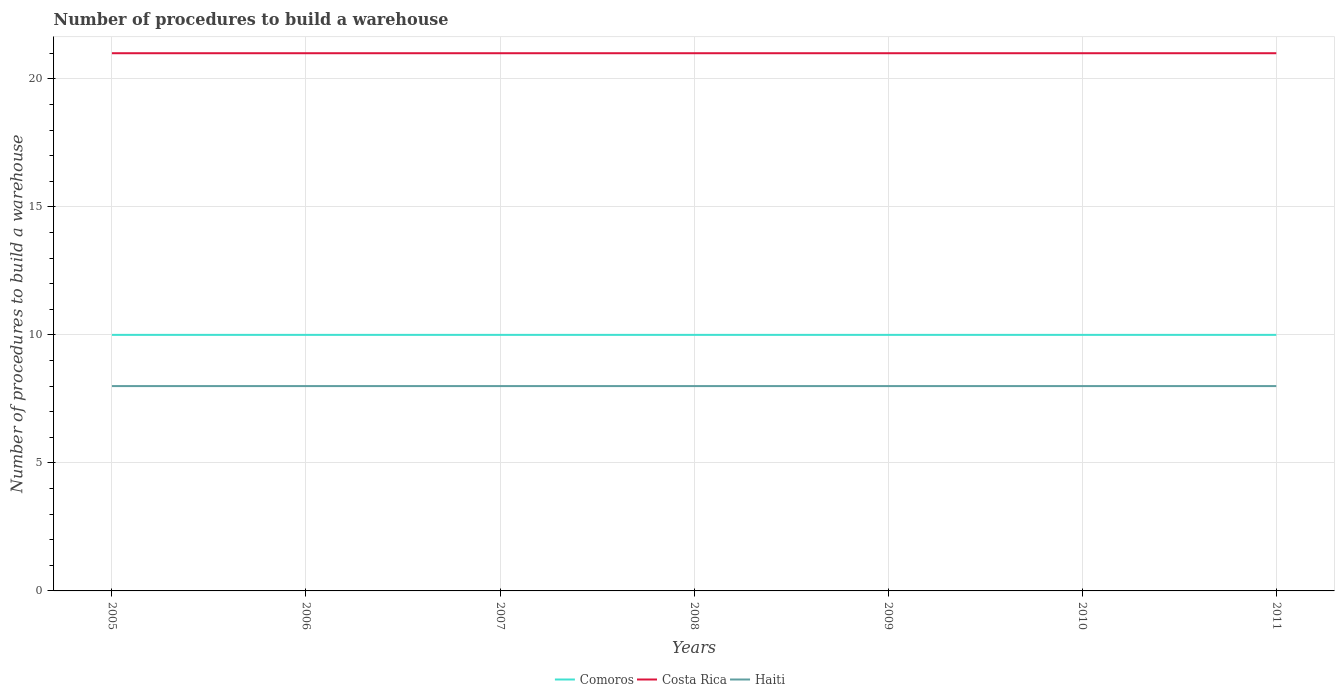Does the line corresponding to Costa Rica intersect with the line corresponding to Haiti?
Your answer should be very brief. No. Across all years, what is the maximum number of procedures to build a warehouse in in Costa Rica?
Your answer should be compact. 21. In which year was the number of procedures to build a warehouse in in Comoros maximum?
Ensure brevity in your answer.  2005. What is the total number of procedures to build a warehouse in in Haiti in the graph?
Provide a succinct answer. 0. What is the difference between the highest and the lowest number of procedures to build a warehouse in in Comoros?
Provide a succinct answer. 0. Are the values on the major ticks of Y-axis written in scientific E-notation?
Provide a short and direct response. No. Does the graph contain grids?
Your answer should be very brief. Yes. How many legend labels are there?
Offer a terse response. 3. What is the title of the graph?
Keep it short and to the point. Number of procedures to build a warehouse. Does "Lesotho" appear as one of the legend labels in the graph?
Your response must be concise. No. What is the label or title of the Y-axis?
Your answer should be very brief. Number of procedures to build a warehouse. What is the Number of procedures to build a warehouse in Costa Rica in 2005?
Your response must be concise. 21. What is the Number of procedures to build a warehouse of Comoros in 2006?
Your answer should be very brief. 10. What is the Number of procedures to build a warehouse of Costa Rica in 2006?
Your response must be concise. 21. What is the Number of procedures to build a warehouse in Haiti in 2006?
Your answer should be very brief. 8. What is the Number of procedures to build a warehouse in Costa Rica in 2007?
Make the answer very short. 21. What is the Number of procedures to build a warehouse in Comoros in 2008?
Provide a short and direct response. 10. What is the Number of procedures to build a warehouse in Costa Rica in 2009?
Ensure brevity in your answer.  21. What is the Number of procedures to build a warehouse of Haiti in 2010?
Provide a succinct answer. 8. What is the Number of procedures to build a warehouse of Comoros in 2011?
Your answer should be very brief. 10. What is the Number of procedures to build a warehouse of Costa Rica in 2011?
Make the answer very short. 21. Across all years, what is the maximum Number of procedures to build a warehouse of Comoros?
Offer a terse response. 10. Across all years, what is the maximum Number of procedures to build a warehouse in Haiti?
Your response must be concise. 8. Across all years, what is the minimum Number of procedures to build a warehouse in Comoros?
Give a very brief answer. 10. What is the total Number of procedures to build a warehouse of Costa Rica in the graph?
Your answer should be very brief. 147. What is the difference between the Number of procedures to build a warehouse of Comoros in 2005 and that in 2006?
Offer a very short reply. 0. What is the difference between the Number of procedures to build a warehouse in Costa Rica in 2005 and that in 2006?
Make the answer very short. 0. What is the difference between the Number of procedures to build a warehouse in Haiti in 2005 and that in 2006?
Your response must be concise. 0. What is the difference between the Number of procedures to build a warehouse of Comoros in 2005 and that in 2007?
Your response must be concise. 0. What is the difference between the Number of procedures to build a warehouse in Haiti in 2005 and that in 2007?
Ensure brevity in your answer.  0. What is the difference between the Number of procedures to build a warehouse in Comoros in 2005 and that in 2009?
Offer a very short reply. 0. What is the difference between the Number of procedures to build a warehouse of Costa Rica in 2005 and that in 2009?
Ensure brevity in your answer.  0. What is the difference between the Number of procedures to build a warehouse of Costa Rica in 2005 and that in 2010?
Provide a short and direct response. 0. What is the difference between the Number of procedures to build a warehouse in Haiti in 2005 and that in 2011?
Make the answer very short. 0. What is the difference between the Number of procedures to build a warehouse of Comoros in 2006 and that in 2008?
Provide a short and direct response. 0. What is the difference between the Number of procedures to build a warehouse of Costa Rica in 2006 and that in 2008?
Your answer should be very brief. 0. What is the difference between the Number of procedures to build a warehouse in Haiti in 2006 and that in 2008?
Make the answer very short. 0. What is the difference between the Number of procedures to build a warehouse in Costa Rica in 2006 and that in 2009?
Your answer should be very brief. 0. What is the difference between the Number of procedures to build a warehouse in Haiti in 2006 and that in 2009?
Keep it short and to the point. 0. What is the difference between the Number of procedures to build a warehouse in Costa Rica in 2006 and that in 2010?
Provide a short and direct response. 0. What is the difference between the Number of procedures to build a warehouse of Comoros in 2007 and that in 2008?
Give a very brief answer. 0. What is the difference between the Number of procedures to build a warehouse of Haiti in 2007 and that in 2008?
Offer a very short reply. 0. What is the difference between the Number of procedures to build a warehouse in Costa Rica in 2007 and that in 2009?
Provide a succinct answer. 0. What is the difference between the Number of procedures to build a warehouse in Costa Rica in 2007 and that in 2010?
Keep it short and to the point. 0. What is the difference between the Number of procedures to build a warehouse of Haiti in 2007 and that in 2010?
Your response must be concise. 0. What is the difference between the Number of procedures to build a warehouse in Comoros in 2007 and that in 2011?
Ensure brevity in your answer.  0. What is the difference between the Number of procedures to build a warehouse of Haiti in 2008 and that in 2009?
Keep it short and to the point. 0. What is the difference between the Number of procedures to build a warehouse in Comoros in 2008 and that in 2010?
Make the answer very short. 0. What is the difference between the Number of procedures to build a warehouse in Costa Rica in 2008 and that in 2010?
Offer a very short reply. 0. What is the difference between the Number of procedures to build a warehouse of Haiti in 2008 and that in 2010?
Keep it short and to the point. 0. What is the difference between the Number of procedures to build a warehouse in Comoros in 2008 and that in 2011?
Provide a succinct answer. 0. What is the difference between the Number of procedures to build a warehouse of Haiti in 2008 and that in 2011?
Give a very brief answer. 0. What is the difference between the Number of procedures to build a warehouse in Costa Rica in 2009 and that in 2011?
Provide a short and direct response. 0. What is the difference between the Number of procedures to build a warehouse in Haiti in 2010 and that in 2011?
Your response must be concise. 0. What is the difference between the Number of procedures to build a warehouse of Comoros in 2005 and the Number of procedures to build a warehouse of Costa Rica in 2006?
Offer a very short reply. -11. What is the difference between the Number of procedures to build a warehouse in Costa Rica in 2005 and the Number of procedures to build a warehouse in Haiti in 2006?
Offer a terse response. 13. What is the difference between the Number of procedures to build a warehouse of Comoros in 2005 and the Number of procedures to build a warehouse of Haiti in 2007?
Provide a succinct answer. 2. What is the difference between the Number of procedures to build a warehouse in Comoros in 2005 and the Number of procedures to build a warehouse in Costa Rica in 2009?
Your response must be concise. -11. What is the difference between the Number of procedures to build a warehouse in Costa Rica in 2005 and the Number of procedures to build a warehouse in Haiti in 2009?
Ensure brevity in your answer.  13. What is the difference between the Number of procedures to build a warehouse of Comoros in 2005 and the Number of procedures to build a warehouse of Costa Rica in 2010?
Give a very brief answer. -11. What is the difference between the Number of procedures to build a warehouse in Comoros in 2005 and the Number of procedures to build a warehouse in Haiti in 2010?
Your answer should be very brief. 2. What is the difference between the Number of procedures to build a warehouse in Costa Rica in 2005 and the Number of procedures to build a warehouse in Haiti in 2010?
Keep it short and to the point. 13. What is the difference between the Number of procedures to build a warehouse in Comoros in 2005 and the Number of procedures to build a warehouse in Costa Rica in 2011?
Your answer should be very brief. -11. What is the difference between the Number of procedures to build a warehouse of Comoros in 2005 and the Number of procedures to build a warehouse of Haiti in 2011?
Offer a very short reply. 2. What is the difference between the Number of procedures to build a warehouse of Comoros in 2006 and the Number of procedures to build a warehouse of Haiti in 2007?
Offer a terse response. 2. What is the difference between the Number of procedures to build a warehouse of Comoros in 2006 and the Number of procedures to build a warehouse of Costa Rica in 2008?
Keep it short and to the point. -11. What is the difference between the Number of procedures to build a warehouse in Comoros in 2006 and the Number of procedures to build a warehouse in Haiti in 2010?
Keep it short and to the point. 2. What is the difference between the Number of procedures to build a warehouse of Costa Rica in 2006 and the Number of procedures to build a warehouse of Haiti in 2010?
Your response must be concise. 13. What is the difference between the Number of procedures to build a warehouse of Comoros in 2007 and the Number of procedures to build a warehouse of Costa Rica in 2008?
Offer a very short reply. -11. What is the difference between the Number of procedures to build a warehouse of Comoros in 2007 and the Number of procedures to build a warehouse of Haiti in 2008?
Offer a very short reply. 2. What is the difference between the Number of procedures to build a warehouse in Costa Rica in 2007 and the Number of procedures to build a warehouse in Haiti in 2008?
Offer a terse response. 13. What is the difference between the Number of procedures to build a warehouse in Comoros in 2007 and the Number of procedures to build a warehouse in Haiti in 2009?
Keep it short and to the point. 2. What is the difference between the Number of procedures to build a warehouse in Costa Rica in 2007 and the Number of procedures to build a warehouse in Haiti in 2009?
Keep it short and to the point. 13. What is the difference between the Number of procedures to build a warehouse of Comoros in 2007 and the Number of procedures to build a warehouse of Costa Rica in 2011?
Offer a terse response. -11. What is the difference between the Number of procedures to build a warehouse of Comoros in 2007 and the Number of procedures to build a warehouse of Haiti in 2011?
Ensure brevity in your answer.  2. What is the difference between the Number of procedures to build a warehouse in Comoros in 2008 and the Number of procedures to build a warehouse in Costa Rica in 2009?
Offer a terse response. -11. What is the difference between the Number of procedures to build a warehouse of Comoros in 2008 and the Number of procedures to build a warehouse of Costa Rica in 2010?
Your answer should be very brief. -11. What is the difference between the Number of procedures to build a warehouse of Comoros in 2008 and the Number of procedures to build a warehouse of Haiti in 2010?
Your response must be concise. 2. What is the difference between the Number of procedures to build a warehouse in Comoros in 2008 and the Number of procedures to build a warehouse in Costa Rica in 2011?
Provide a succinct answer. -11. What is the difference between the Number of procedures to build a warehouse of Comoros in 2009 and the Number of procedures to build a warehouse of Haiti in 2010?
Provide a succinct answer. 2. What is the difference between the Number of procedures to build a warehouse of Costa Rica in 2009 and the Number of procedures to build a warehouse of Haiti in 2010?
Make the answer very short. 13. What is the difference between the Number of procedures to build a warehouse in Comoros in 2009 and the Number of procedures to build a warehouse in Costa Rica in 2011?
Keep it short and to the point. -11. What is the difference between the Number of procedures to build a warehouse in Comoros in 2009 and the Number of procedures to build a warehouse in Haiti in 2011?
Your answer should be very brief. 2. What is the difference between the Number of procedures to build a warehouse of Costa Rica in 2010 and the Number of procedures to build a warehouse of Haiti in 2011?
Ensure brevity in your answer.  13. What is the average Number of procedures to build a warehouse in Costa Rica per year?
Offer a very short reply. 21. In the year 2005, what is the difference between the Number of procedures to build a warehouse in Costa Rica and Number of procedures to build a warehouse in Haiti?
Keep it short and to the point. 13. In the year 2006, what is the difference between the Number of procedures to build a warehouse in Comoros and Number of procedures to build a warehouse in Haiti?
Make the answer very short. 2. In the year 2007, what is the difference between the Number of procedures to build a warehouse in Comoros and Number of procedures to build a warehouse in Costa Rica?
Your answer should be compact. -11. In the year 2007, what is the difference between the Number of procedures to build a warehouse of Costa Rica and Number of procedures to build a warehouse of Haiti?
Keep it short and to the point. 13. In the year 2008, what is the difference between the Number of procedures to build a warehouse in Comoros and Number of procedures to build a warehouse in Costa Rica?
Provide a short and direct response. -11. In the year 2009, what is the difference between the Number of procedures to build a warehouse of Comoros and Number of procedures to build a warehouse of Costa Rica?
Offer a terse response. -11. In the year 2009, what is the difference between the Number of procedures to build a warehouse in Costa Rica and Number of procedures to build a warehouse in Haiti?
Ensure brevity in your answer.  13. In the year 2010, what is the difference between the Number of procedures to build a warehouse in Comoros and Number of procedures to build a warehouse in Haiti?
Keep it short and to the point. 2. In the year 2011, what is the difference between the Number of procedures to build a warehouse in Comoros and Number of procedures to build a warehouse in Haiti?
Give a very brief answer. 2. What is the ratio of the Number of procedures to build a warehouse of Comoros in 2005 to that in 2006?
Offer a terse response. 1. What is the ratio of the Number of procedures to build a warehouse in Haiti in 2005 to that in 2006?
Keep it short and to the point. 1. What is the ratio of the Number of procedures to build a warehouse in Comoros in 2005 to that in 2008?
Ensure brevity in your answer.  1. What is the ratio of the Number of procedures to build a warehouse in Comoros in 2005 to that in 2009?
Give a very brief answer. 1. What is the ratio of the Number of procedures to build a warehouse in Haiti in 2005 to that in 2009?
Your answer should be compact. 1. What is the ratio of the Number of procedures to build a warehouse of Comoros in 2005 to that in 2010?
Give a very brief answer. 1. What is the ratio of the Number of procedures to build a warehouse of Haiti in 2005 to that in 2010?
Offer a very short reply. 1. What is the ratio of the Number of procedures to build a warehouse in Comoros in 2006 to that in 2007?
Your answer should be compact. 1. What is the ratio of the Number of procedures to build a warehouse in Comoros in 2006 to that in 2008?
Your response must be concise. 1. What is the ratio of the Number of procedures to build a warehouse of Comoros in 2006 to that in 2009?
Make the answer very short. 1. What is the ratio of the Number of procedures to build a warehouse of Haiti in 2006 to that in 2009?
Your answer should be very brief. 1. What is the ratio of the Number of procedures to build a warehouse of Comoros in 2006 to that in 2010?
Offer a very short reply. 1. What is the ratio of the Number of procedures to build a warehouse of Costa Rica in 2006 to that in 2010?
Your response must be concise. 1. What is the ratio of the Number of procedures to build a warehouse of Haiti in 2006 to that in 2010?
Ensure brevity in your answer.  1. What is the ratio of the Number of procedures to build a warehouse in Comoros in 2006 to that in 2011?
Your response must be concise. 1. What is the ratio of the Number of procedures to build a warehouse in Haiti in 2006 to that in 2011?
Offer a terse response. 1. What is the ratio of the Number of procedures to build a warehouse of Comoros in 2007 to that in 2008?
Ensure brevity in your answer.  1. What is the ratio of the Number of procedures to build a warehouse of Costa Rica in 2007 to that in 2008?
Your response must be concise. 1. What is the ratio of the Number of procedures to build a warehouse in Comoros in 2007 to that in 2009?
Provide a short and direct response. 1. What is the ratio of the Number of procedures to build a warehouse in Costa Rica in 2007 to that in 2009?
Give a very brief answer. 1. What is the ratio of the Number of procedures to build a warehouse of Costa Rica in 2007 to that in 2010?
Keep it short and to the point. 1. What is the ratio of the Number of procedures to build a warehouse of Costa Rica in 2008 to that in 2009?
Offer a very short reply. 1. What is the ratio of the Number of procedures to build a warehouse of Haiti in 2008 to that in 2010?
Your answer should be very brief. 1. What is the ratio of the Number of procedures to build a warehouse of Costa Rica in 2008 to that in 2011?
Your answer should be compact. 1. What is the ratio of the Number of procedures to build a warehouse of Haiti in 2008 to that in 2011?
Provide a short and direct response. 1. What is the ratio of the Number of procedures to build a warehouse of Costa Rica in 2010 to that in 2011?
Keep it short and to the point. 1. What is the ratio of the Number of procedures to build a warehouse of Haiti in 2010 to that in 2011?
Keep it short and to the point. 1. What is the difference between the highest and the second highest Number of procedures to build a warehouse of Comoros?
Give a very brief answer. 0. What is the difference between the highest and the second highest Number of procedures to build a warehouse of Costa Rica?
Your answer should be very brief. 0. What is the difference between the highest and the second highest Number of procedures to build a warehouse of Haiti?
Give a very brief answer. 0. What is the difference between the highest and the lowest Number of procedures to build a warehouse in Comoros?
Your answer should be compact. 0. What is the difference between the highest and the lowest Number of procedures to build a warehouse of Costa Rica?
Give a very brief answer. 0. 